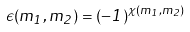Convert formula to latex. <formula><loc_0><loc_0><loc_500><loc_500>\epsilon ( m _ { 1 } , m _ { 2 } ) = ( - 1 ) ^ { \chi ( m _ { 1 } , m _ { 2 } ) }</formula> 